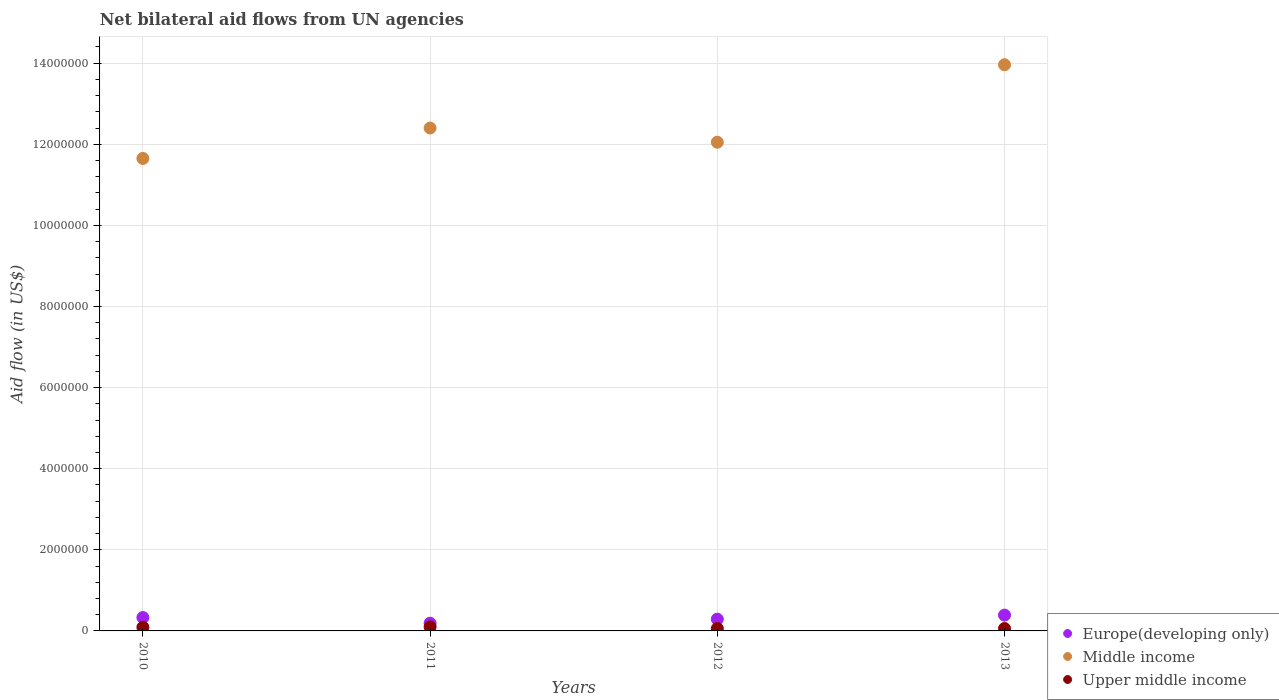How many different coloured dotlines are there?
Give a very brief answer. 3. What is the net bilateral aid flow in Upper middle income in 2012?
Offer a very short reply. 6.00e+04. Across all years, what is the maximum net bilateral aid flow in Upper middle income?
Your answer should be compact. 1.00e+05. Across all years, what is the minimum net bilateral aid flow in Upper middle income?
Give a very brief answer. 6.00e+04. In which year was the net bilateral aid flow in Europe(developing only) maximum?
Your answer should be compact. 2013. In which year was the net bilateral aid flow in Middle income minimum?
Your answer should be compact. 2010. What is the total net bilateral aid flow in Middle income in the graph?
Give a very brief answer. 5.01e+07. What is the difference between the net bilateral aid flow in Upper middle income in 2010 and that in 2013?
Ensure brevity in your answer.  3.00e+04. What is the difference between the net bilateral aid flow in Upper middle income in 2011 and the net bilateral aid flow in Middle income in 2012?
Your answer should be very brief. -1.20e+07. What is the average net bilateral aid flow in Middle income per year?
Offer a very short reply. 1.25e+07. In the year 2011, what is the difference between the net bilateral aid flow in Upper middle income and net bilateral aid flow in Europe(developing only)?
Give a very brief answer. -9.00e+04. In how many years, is the net bilateral aid flow in Europe(developing only) greater than 12400000 US$?
Make the answer very short. 0. What is the ratio of the net bilateral aid flow in Europe(developing only) in 2010 to that in 2013?
Provide a succinct answer. 0.85. What is the difference between the highest and the lowest net bilateral aid flow in Upper middle income?
Offer a terse response. 4.00e+04. Is the sum of the net bilateral aid flow in Europe(developing only) in 2010 and 2013 greater than the maximum net bilateral aid flow in Middle income across all years?
Make the answer very short. No. Is it the case that in every year, the sum of the net bilateral aid flow in Middle income and net bilateral aid flow in Europe(developing only)  is greater than the net bilateral aid flow in Upper middle income?
Provide a short and direct response. Yes. Does the net bilateral aid flow in Europe(developing only) monotonically increase over the years?
Keep it short and to the point. No. Is the net bilateral aid flow in Europe(developing only) strictly greater than the net bilateral aid flow in Middle income over the years?
Keep it short and to the point. No. Is the net bilateral aid flow in Europe(developing only) strictly less than the net bilateral aid flow in Middle income over the years?
Your answer should be compact. Yes. How many dotlines are there?
Offer a terse response. 3. How many years are there in the graph?
Offer a terse response. 4. Are the values on the major ticks of Y-axis written in scientific E-notation?
Make the answer very short. No. Where does the legend appear in the graph?
Keep it short and to the point. Bottom right. How many legend labels are there?
Offer a terse response. 3. What is the title of the graph?
Your answer should be very brief. Net bilateral aid flows from UN agencies. Does "Kosovo" appear as one of the legend labels in the graph?
Make the answer very short. No. What is the label or title of the Y-axis?
Your answer should be very brief. Aid flow (in US$). What is the Aid flow (in US$) of Middle income in 2010?
Your answer should be very brief. 1.16e+07. What is the Aid flow (in US$) in Upper middle income in 2010?
Keep it short and to the point. 9.00e+04. What is the Aid flow (in US$) in Europe(developing only) in 2011?
Ensure brevity in your answer.  1.90e+05. What is the Aid flow (in US$) of Middle income in 2011?
Your answer should be very brief. 1.24e+07. What is the Aid flow (in US$) of Upper middle income in 2011?
Give a very brief answer. 1.00e+05. What is the Aid flow (in US$) in Middle income in 2012?
Offer a terse response. 1.20e+07. What is the Aid flow (in US$) of Upper middle income in 2012?
Your answer should be compact. 6.00e+04. What is the Aid flow (in US$) in Europe(developing only) in 2013?
Ensure brevity in your answer.  3.90e+05. What is the Aid flow (in US$) of Middle income in 2013?
Offer a very short reply. 1.40e+07. What is the Aid flow (in US$) of Upper middle income in 2013?
Ensure brevity in your answer.  6.00e+04. Across all years, what is the maximum Aid flow (in US$) of Europe(developing only)?
Your answer should be very brief. 3.90e+05. Across all years, what is the maximum Aid flow (in US$) of Middle income?
Provide a succinct answer. 1.40e+07. Across all years, what is the minimum Aid flow (in US$) of Middle income?
Your response must be concise. 1.16e+07. What is the total Aid flow (in US$) of Europe(developing only) in the graph?
Offer a very short reply. 1.20e+06. What is the total Aid flow (in US$) of Middle income in the graph?
Ensure brevity in your answer.  5.01e+07. What is the total Aid flow (in US$) of Upper middle income in the graph?
Your answer should be very brief. 3.10e+05. What is the difference between the Aid flow (in US$) in Middle income in 2010 and that in 2011?
Provide a short and direct response. -7.50e+05. What is the difference between the Aid flow (in US$) in Europe(developing only) in 2010 and that in 2012?
Your response must be concise. 4.00e+04. What is the difference between the Aid flow (in US$) in Middle income in 2010 and that in 2012?
Your answer should be very brief. -4.00e+05. What is the difference between the Aid flow (in US$) of Upper middle income in 2010 and that in 2012?
Provide a succinct answer. 3.00e+04. What is the difference between the Aid flow (in US$) of Europe(developing only) in 2010 and that in 2013?
Ensure brevity in your answer.  -6.00e+04. What is the difference between the Aid flow (in US$) of Middle income in 2010 and that in 2013?
Give a very brief answer. -2.31e+06. What is the difference between the Aid flow (in US$) in Upper middle income in 2010 and that in 2013?
Your answer should be compact. 3.00e+04. What is the difference between the Aid flow (in US$) in Europe(developing only) in 2011 and that in 2012?
Give a very brief answer. -1.00e+05. What is the difference between the Aid flow (in US$) in Middle income in 2011 and that in 2013?
Provide a short and direct response. -1.56e+06. What is the difference between the Aid flow (in US$) of Europe(developing only) in 2012 and that in 2013?
Offer a very short reply. -1.00e+05. What is the difference between the Aid flow (in US$) of Middle income in 2012 and that in 2013?
Give a very brief answer. -1.91e+06. What is the difference between the Aid flow (in US$) in Europe(developing only) in 2010 and the Aid flow (in US$) in Middle income in 2011?
Make the answer very short. -1.21e+07. What is the difference between the Aid flow (in US$) in Middle income in 2010 and the Aid flow (in US$) in Upper middle income in 2011?
Provide a short and direct response. 1.16e+07. What is the difference between the Aid flow (in US$) in Europe(developing only) in 2010 and the Aid flow (in US$) in Middle income in 2012?
Keep it short and to the point. -1.17e+07. What is the difference between the Aid flow (in US$) in Middle income in 2010 and the Aid flow (in US$) in Upper middle income in 2012?
Offer a very short reply. 1.16e+07. What is the difference between the Aid flow (in US$) in Europe(developing only) in 2010 and the Aid flow (in US$) in Middle income in 2013?
Give a very brief answer. -1.36e+07. What is the difference between the Aid flow (in US$) in Middle income in 2010 and the Aid flow (in US$) in Upper middle income in 2013?
Give a very brief answer. 1.16e+07. What is the difference between the Aid flow (in US$) in Europe(developing only) in 2011 and the Aid flow (in US$) in Middle income in 2012?
Ensure brevity in your answer.  -1.19e+07. What is the difference between the Aid flow (in US$) of Europe(developing only) in 2011 and the Aid flow (in US$) of Upper middle income in 2012?
Your response must be concise. 1.30e+05. What is the difference between the Aid flow (in US$) in Middle income in 2011 and the Aid flow (in US$) in Upper middle income in 2012?
Offer a very short reply. 1.23e+07. What is the difference between the Aid flow (in US$) of Europe(developing only) in 2011 and the Aid flow (in US$) of Middle income in 2013?
Offer a very short reply. -1.38e+07. What is the difference between the Aid flow (in US$) of Middle income in 2011 and the Aid flow (in US$) of Upper middle income in 2013?
Offer a very short reply. 1.23e+07. What is the difference between the Aid flow (in US$) of Europe(developing only) in 2012 and the Aid flow (in US$) of Middle income in 2013?
Provide a succinct answer. -1.37e+07. What is the difference between the Aid flow (in US$) in Middle income in 2012 and the Aid flow (in US$) in Upper middle income in 2013?
Your answer should be compact. 1.20e+07. What is the average Aid flow (in US$) in Middle income per year?
Offer a terse response. 1.25e+07. What is the average Aid flow (in US$) of Upper middle income per year?
Your answer should be compact. 7.75e+04. In the year 2010, what is the difference between the Aid flow (in US$) in Europe(developing only) and Aid flow (in US$) in Middle income?
Your answer should be compact. -1.13e+07. In the year 2010, what is the difference between the Aid flow (in US$) of Europe(developing only) and Aid flow (in US$) of Upper middle income?
Offer a terse response. 2.40e+05. In the year 2010, what is the difference between the Aid flow (in US$) of Middle income and Aid flow (in US$) of Upper middle income?
Your answer should be compact. 1.16e+07. In the year 2011, what is the difference between the Aid flow (in US$) in Europe(developing only) and Aid flow (in US$) in Middle income?
Your answer should be very brief. -1.22e+07. In the year 2011, what is the difference between the Aid flow (in US$) of Middle income and Aid flow (in US$) of Upper middle income?
Provide a succinct answer. 1.23e+07. In the year 2012, what is the difference between the Aid flow (in US$) of Europe(developing only) and Aid flow (in US$) of Middle income?
Make the answer very short. -1.18e+07. In the year 2012, what is the difference between the Aid flow (in US$) of Europe(developing only) and Aid flow (in US$) of Upper middle income?
Provide a succinct answer. 2.30e+05. In the year 2012, what is the difference between the Aid flow (in US$) of Middle income and Aid flow (in US$) of Upper middle income?
Provide a succinct answer. 1.20e+07. In the year 2013, what is the difference between the Aid flow (in US$) in Europe(developing only) and Aid flow (in US$) in Middle income?
Your response must be concise. -1.36e+07. In the year 2013, what is the difference between the Aid flow (in US$) of Middle income and Aid flow (in US$) of Upper middle income?
Your answer should be compact. 1.39e+07. What is the ratio of the Aid flow (in US$) of Europe(developing only) in 2010 to that in 2011?
Your response must be concise. 1.74. What is the ratio of the Aid flow (in US$) in Middle income in 2010 to that in 2011?
Make the answer very short. 0.94. What is the ratio of the Aid flow (in US$) of Europe(developing only) in 2010 to that in 2012?
Provide a short and direct response. 1.14. What is the ratio of the Aid flow (in US$) of Middle income in 2010 to that in 2012?
Your answer should be compact. 0.97. What is the ratio of the Aid flow (in US$) of Upper middle income in 2010 to that in 2012?
Ensure brevity in your answer.  1.5. What is the ratio of the Aid flow (in US$) in Europe(developing only) in 2010 to that in 2013?
Give a very brief answer. 0.85. What is the ratio of the Aid flow (in US$) of Middle income in 2010 to that in 2013?
Give a very brief answer. 0.83. What is the ratio of the Aid flow (in US$) of Upper middle income in 2010 to that in 2013?
Keep it short and to the point. 1.5. What is the ratio of the Aid flow (in US$) of Europe(developing only) in 2011 to that in 2012?
Provide a succinct answer. 0.66. What is the ratio of the Aid flow (in US$) of Middle income in 2011 to that in 2012?
Offer a terse response. 1.03. What is the ratio of the Aid flow (in US$) in Upper middle income in 2011 to that in 2012?
Your answer should be compact. 1.67. What is the ratio of the Aid flow (in US$) of Europe(developing only) in 2011 to that in 2013?
Offer a terse response. 0.49. What is the ratio of the Aid flow (in US$) in Middle income in 2011 to that in 2013?
Provide a succinct answer. 0.89. What is the ratio of the Aid flow (in US$) in Europe(developing only) in 2012 to that in 2013?
Provide a succinct answer. 0.74. What is the ratio of the Aid flow (in US$) of Middle income in 2012 to that in 2013?
Keep it short and to the point. 0.86. What is the difference between the highest and the second highest Aid flow (in US$) in Europe(developing only)?
Provide a short and direct response. 6.00e+04. What is the difference between the highest and the second highest Aid flow (in US$) of Middle income?
Provide a succinct answer. 1.56e+06. What is the difference between the highest and the lowest Aid flow (in US$) of Middle income?
Give a very brief answer. 2.31e+06. What is the difference between the highest and the lowest Aid flow (in US$) in Upper middle income?
Your answer should be very brief. 4.00e+04. 